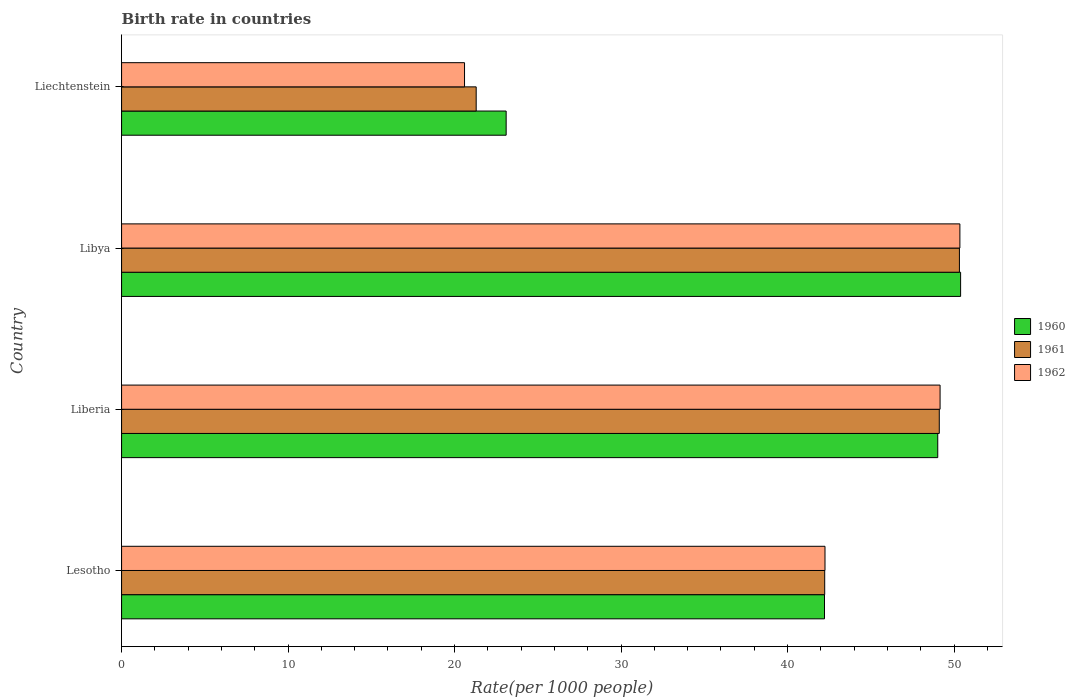Are the number of bars on each tick of the Y-axis equal?
Make the answer very short. Yes. How many bars are there on the 3rd tick from the bottom?
Provide a succinct answer. 3. What is the label of the 3rd group of bars from the top?
Offer a terse response. Liberia. What is the birth rate in 1962 in Lesotho?
Offer a very short reply. 42.25. Across all countries, what is the maximum birth rate in 1960?
Ensure brevity in your answer.  50.4. Across all countries, what is the minimum birth rate in 1962?
Give a very brief answer. 20.6. In which country was the birth rate in 1960 maximum?
Your answer should be compact. Libya. In which country was the birth rate in 1961 minimum?
Offer a terse response. Liechtenstein. What is the total birth rate in 1962 in the graph?
Your response must be concise. 162.37. What is the difference between the birth rate in 1960 in Libya and that in Liechtenstein?
Give a very brief answer. 27.3. What is the difference between the birth rate in 1962 in Libya and the birth rate in 1960 in Liechtenstein?
Make the answer very short. 27.25. What is the average birth rate in 1960 per country?
Your answer should be compact. 41.19. What is the ratio of the birth rate in 1961 in Lesotho to that in Liberia?
Your answer should be very brief. 0.86. What is the difference between the highest and the second highest birth rate in 1962?
Give a very brief answer. 1.19. What is the difference between the highest and the lowest birth rate in 1960?
Provide a succinct answer. 27.3. In how many countries, is the birth rate in 1962 greater than the average birth rate in 1962 taken over all countries?
Ensure brevity in your answer.  3. Is the sum of the birth rate in 1962 in Lesotho and Libya greater than the maximum birth rate in 1960 across all countries?
Provide a short and direct response. Yes. What does the 2nd bar from the top in Lesotho represents?
Provide a short and direct response. 1961. What does the 1st bar from the bottom in Lesotho represents?
Offer a terse response. 1960. How many bars are there?
Your answer should be compact. 12. Are all the bars in the graph horizontal?
Provide a succinct answer. Yes. Are the values on the major ticks of X-axis written in scientific E-notation?
Provide a short and direct response. No. Where does the legend appear in the graph?
Your answer should be compact. Center right. What is the title of the graph?
Provide a succinct answer. Birth rate in countries. Does "2004" appear as one of the legend labels in the graph?
Provide a succinct answer. No. What is the label or title of the X-axis?
Provide a short and direct response. Rate(per 1000 people). What is the Rate(per 1000 people) in 1960 in Lesotho?
Your answer should be compact. 42.22. What is the Rate(per 1000 people) of 1961 in Lesotho?
Provide a short and direct response. 42.23. What is the Rate(per 1000 people) in 1962 in Lesotho?
Your answer should be compact. 42.25. What is the Rate(per 1000 people) in 1960 in Liberia?
Provide a short and direct response. 49.02. What is the Rate(per 1000 people) of 1961 in Liberia?
Offer a very short reply. 49.12. What is the Rate(per 1000 people) of 1962 in Liberia?
Give a very brief answer. 49.16. What is the Rate(per 1000 people) in 1960 in Libya?
Ensure brevity in your answer.  50.4. What is the Rate(per 1000 people) in 1961 in Libya?
Ensure brevity in your answer.  50.33. What is the Rate(per 1000 people) in 1962 in Libya?
Provide a succinct answer. 50.35. What is the Rate(per 1000 people) in 1960 in Liechtenstein?
Your answer should be very brief. 23.1. What is the Rate(per 1000 people) of 1961 in Liechtenstein?
Provide a short and direct response. 21.3. What is the Rate(per 1000 people) in 1962 in Liechtenstein?
Your response must be concise. 20.6. Across all countries, what is the maximum Rate(per 1000 people) in 1960?
Provide a succinct answer. 50.4. Across all countries, what is the maximum Rate(per 1000 people) in 1961?
Make the answer very short. 50.33. Across all countries, what is the maximum Rate(per 1000 people) in 1962?
Provide a succinct answer. 50.35. Across all countries, what is the minimum Rate(per 1000 people) of 1960?
Make the answer very short. 23.1. Across all countries, what is the minimum Rate(per 1000 people) of 1961?
Provide a short and direct response. 21.3. Across all countries, what is the minimum Rate(per 1000 people) of 1962?
Offer a very short reply. 20.6. What is the total Rate(per 1000 people) of 1960 in the graph?
Offer a terse response. 164.74. What is the total Rate(per 1000 people) of 1961 in the graph?
Your answer should be very brief. 162.98. What is the total Rate(per 1000 people) of 1962 in the graph?
Provide a succinct answer. 162.37. What is the difference between the Rate(per 1000 people) in 1960 in Lesotho and that in Liberia?
Provide a succinct answer. -6.8. What is the difference between the Rate(per 1000 people) of 1961 in Lesotho and that in Liberia?
Ensure brevity in your answer.  -6.88. What is the difference between the Rate(per 1000 people) of 1962 in Lesotho and that in Liberia?
Your answer should be compact. -6.91. What is the difference between the Rate(per 1000 people) of 1960 in Lesotho and that in Libya?
Your answer should be compact. -8.18. What is the difference between the Rate(per 1000 people) of 1961 in Lesotho and that in Libya?
Offer a terse response. -8.09. What is the difference between the Rate(per 1000 people) of 1962 in Lesotho and that in Libya?
Your answer should be compact. -8.1. What is the difference between the Rate(per 1000 people) in 1960 in Lesotho and that in Liechtenstein?
Your answer should be very brief. 19.12. What is the difference between the Rate(per 1000 people) of 1961 in Lesotho and that in Liechtenstein?
Offer a terse response. 20.93. What is the difference between the Rate(per 1000 people) in 1962 in Lesotho and that in Liechtenstein?
Keep it short and to the point. 21.65. What is the difference between the Rate(per 1000 people) of 1960 in Liberia and that in Libya?
Your answer should be very brief. -1.37. What is the difference between the Rate(per 1000 people) in 1961 in Liberia and that in Libya?
Provide a succinct answer. -1.21. What is the difference between the Rate(per 1000 people) in 1962 in Liberia and that in Libya?
Provide a short and direct response. -1.19. What is the difference between the Rate(per 1000 people) of 1960 in Liberia and that in Liechtenstein?
Offer a very short reply. 25.92. What is the difference between the Rate(per 1000 people) of 1961 in Liberia and that in Liechtenstein?
Offer a very short reply. 27.82. What is the difference between the Rate(per 1000 people) in 1962 in Liberia and that in Liechtenstein?
Your answer should be very brief. 28.56. What is the difference between the Rate(per 1000 people) of 1960 in Libya and that in Liechtenstein?
Your answer should be very brief. 27.3. What is the difference between the Rate(per 1000 people) in 1961 in Libya and that in Liechtenstein?
Offer a very short reply. 29.03. What is the difference between the Rate(per 1000 people) of 1962 in Libya and that in Liechtenstein?
Give a very brief answer. 29.75. What is the difference between the Rate(per 1000 people) in 1960 in Lesotho and the Rate(per 1000 people) in 1961 in Liberia?
Give a very brief answer. -6.89. What is the difference between the Rate(per 1000 people) of 1960 in Lesotho and the Rate(per 1000 people) of 1962 in Liberia?
Offer a very short reply. -6.94. What is the difference between the Rate(per 1000 people) in 1961 in Lesotho and the Rate(per 1000 people) in 1962 in Liberia?
Your response must be concise. -6.93. What is the difference between the Rate(per 1000 people) in 1960 in Lesotho and the Rate(per 1000 people) in 1961 in Libya?
Give a very brief answer. -8.1. What is the difference between the Rate(per 1000 people) in 1960 in Lesotho and the Rate(per 1000 people) in 1962 in Libya?
Keep it short and to the point. -8.13. What is the difference between the Rate(per 1000 people) in 1961 in Lesotho and the Rate(per 1000 people) in 1962 in Libya?
Ensure brevity in your answer.  -8.12. What is the difference between the Rate(per 1000 people) in 1960 in Lesotho and the Rate(per 1000 people) in 1961 in Liechtenstein?
Offer a terse response. 20.92. What is the difference between the Rate(per 1000 people) in 1960 in Lesotho and the Rate(per 1000 people) in 1962 in Liechtenstein?
Offer a terse response. 21.62. What is the difference between the Rate(per 1000 people) in 1961 in Lesotho and the Rate(per 1000 people) in 1962 in Liechtenstein?
Provide a succinct answer. 21.63. What is the difference between the Rate(per 1000 people) in 1960 in Liberia and the Rate(per 1000 people) in 1961 in Libya?
Provide a short and direct response. -1.3. What is the difference between the Rate(per 1000 people) of 1960 in Liberia and the Rate(per 1000 people) of 1962 in Libya?
Your response must be concise. -1.33. What is the difference between the Rate(per 1000 people) of 1961 in Liberia and the Rate(per 1000 people) of 1962 in Libya?
Provide a short and direct response. -1.24. What is the difference between the Rate(per 1000 people) in 1960 in Liberia and the Rate(per 1000 people) in 1961 in Liechtenstein?
Provide a succinct answer. 27.72. What is the difference between the Rate(per 1000 people) of 1960 in Liberia and the Rate(per 1000 people) of 1962 in Liechtenstein?
Your response must be concise. 28.42. What is the difference between the Rate(per 1000 people) of 1961 in Liberia and the Rate(per 1000 people) of 1962 in Liechtenstein?
Your answer should be compact. 28.52. What is the difference between the Rate(per 1000 people) of 1960 in Libya and the Rate(per 1000 people) of 1961 in Liechtenstein?
Give a very brief answer. 29.1. What is the difference between the Rate(per 1000 people) in 1960 in Libya and the Rate(per 1000 people) in 1962 in Liechtenstein?
Make the answer very short. 29.8. What is the difference between the Rate(per 1000 people) in 1961 in Libya and the Rate(per 1000 people) in 1962 in Liechtenstein?
Provide a short and direct response. 29.73. What is the average Rate(per 1000 people) in 1960 per country?
Offer a terse response. 41.19. What is the average Rate(per 1000 people) in 1961 per country?
Your answer should be very brief. 40.74. What is the average Rate(per 1000 people) of 1962 per country?
Give a very brief answer. 40.59. What is the difference between the Rate(per 1000 people) in 1960 and Rate(per 1000 people) in 1961 in Lesotho?
Keep it short and to the point. -0.01. What is the difference between the Rate(per 1000 people) in 1960 and Rate(per 1000 people) in 1962 in Lesotho?
Make the answer very short. -0.03. What is the difference between the Rate(per 1000 people) in 1961 and Rate(per 1000 people) in 1962 in Lesotho?
Your answer should be very brief. -0.02. What is the difference between the Rate(per 1000 people) of 1960 and Rate(per 1000 people) of 1961 in Liberia?
Ensure brevity in your answer.  -0.09. What is the difference between the Rate(per 1000 people) in 1960 and Rate(per 1000 people) in 1962 in Liberia?
Your answer should be very brief. -0.14. What is the difference between the Rate(per 1000 people) in 1961 and Rate(per 1000 people) in 1962 in Liberia?
Offer a very short reply. -0.05. What is the difference between the Rate(per 1000 people) of 1960 and Rate(per 1000 people) of 1961 in Libya?
Ensure brevity in your answer.  0.07. What is the difference between the Rate(per 1000 people) of 1960 and Rate(per 1000 people) of 1962 in Libya?
Provide a succinct answer. 0.04. What is the difference between the Rate(per 1000 people) of 1961 and Rate(per 1000 people) of 1962 in Libya?
Keep it short and to the point. -0.03. What is the difference between the Rate(per 1000 people) in 1960 and Rate(per 1000 people) in 1962 in Liechtenstein?
Give a very brief answer. 2.5. What is the difference between the Rate(per 1000 people) of 1961 and Rate(per 1000 people) of 1962 in Liechtenstein?
Your answer should be compact. 0.7. What is the ratio of the Rate(per 1000 people) in 1960 in Lesotho to that in Liberia?
Your answer should be very brief. 0.86. What is the ratio of the Rate(per 1000 people) of 1961 in Lesotho to that in Liberia?
Offer a very short reply. 0.86. What is the ratio of the Rate(per 1000 people) in 1962 in Lesotho to that in Liberia?
Provide a succinct answer. 0.86. What is the ratio of the Rate(per 1000 people) in 1960 in Lesotho to that in Libya?
Offer a very short reply. 0.84. What is the ratio of the Rate(per 1000 people) in 1961 in Lesotho to that in Libya?
Keep it short and to the point. 0.84. What is the ratio of the Rate(per 1000 people) in 1962 in Lesotho to that in Libya?
Your answer should be very brief. 0.84. What is the ratio of the Rate(per 1000 people) in 1960 in Lesotho to that in Liechtenstein?
Provide a short and direct response. 1.83. What is the ratio of the Rate(per 1000 people) in 1961 in Lesotho to that in Liechtenstein?
Your answer should be very brief. 1.98. What is the ratio of the Rate(per 1000 people) in 1962 in Lesotho to that in Liechtenstein?
Your response must be concise. 2.05. What is the ratio of the Rate(per 1000 people) in 1960 in Liberia to that in Libya?
Your response must be concise. 0.97. What is the ratio of the Rate(per 1000 people) in 1962 in Liberia to that in Libya?
Give a very brief answer. 0.98. What is the ratio of the Rate(per 1000 people) of 1960 in Liberia to that in Liechtenstein?
Keep it short and to the point. 2.12. What is the ratio of the Rate(per 1000 people) of 1961 in Liberia to that in Liechtenstein?
Your response must be concise. 2.31. What is the ratio of the Rate(per 1000 people) of 1962 in Liberia to that in Liechtenstein?
Provide a succinct answer. 2.39. What is the ratio of the Rate(per 1000 people) of 1960 in Libya to that in Liechtenstein?
Your response must be concise. 2.18. What is the ratio of the Rate(per 1000 people) of 1961 in Libya to that in Liechtenstein?
Your response must be concise. 2.36. What is the ratio of the Rate(per 1000 people) of 1962 in Libya to that in Liechtenstein?
Your answer should be very brief. 2.44. What is the difference between the highest and the second highest Rate(per 1000 people) in 1960?
Your answer should be compact. 1.37. What is the difference between the highest and the second highest Rate(per 1000 people) in 1961?
Offer a terse response. 1.21. What is the difference between the highest and the second highest Rate(per 1000 people) of 1962?
Make the answer very short. 1.19. What is the difference between the highest and the lowest Rate(per 1000 people) of 1960?
Ensure brevity in your answer.  27.3. What is the difference between the highest and the lowest Rate(per 1000 people) in 1961?
Give a very brief answer. 29.03. What is the difference between the highest and the lowest Rate(per 1000 people) of 1962?
Offer a very short reply. 29.75. 